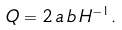<formula> <loc_0><loc_0><loc_500><loc_500>Q = 2 \, a \, b \, H ^ { - 1 } .</formula> 